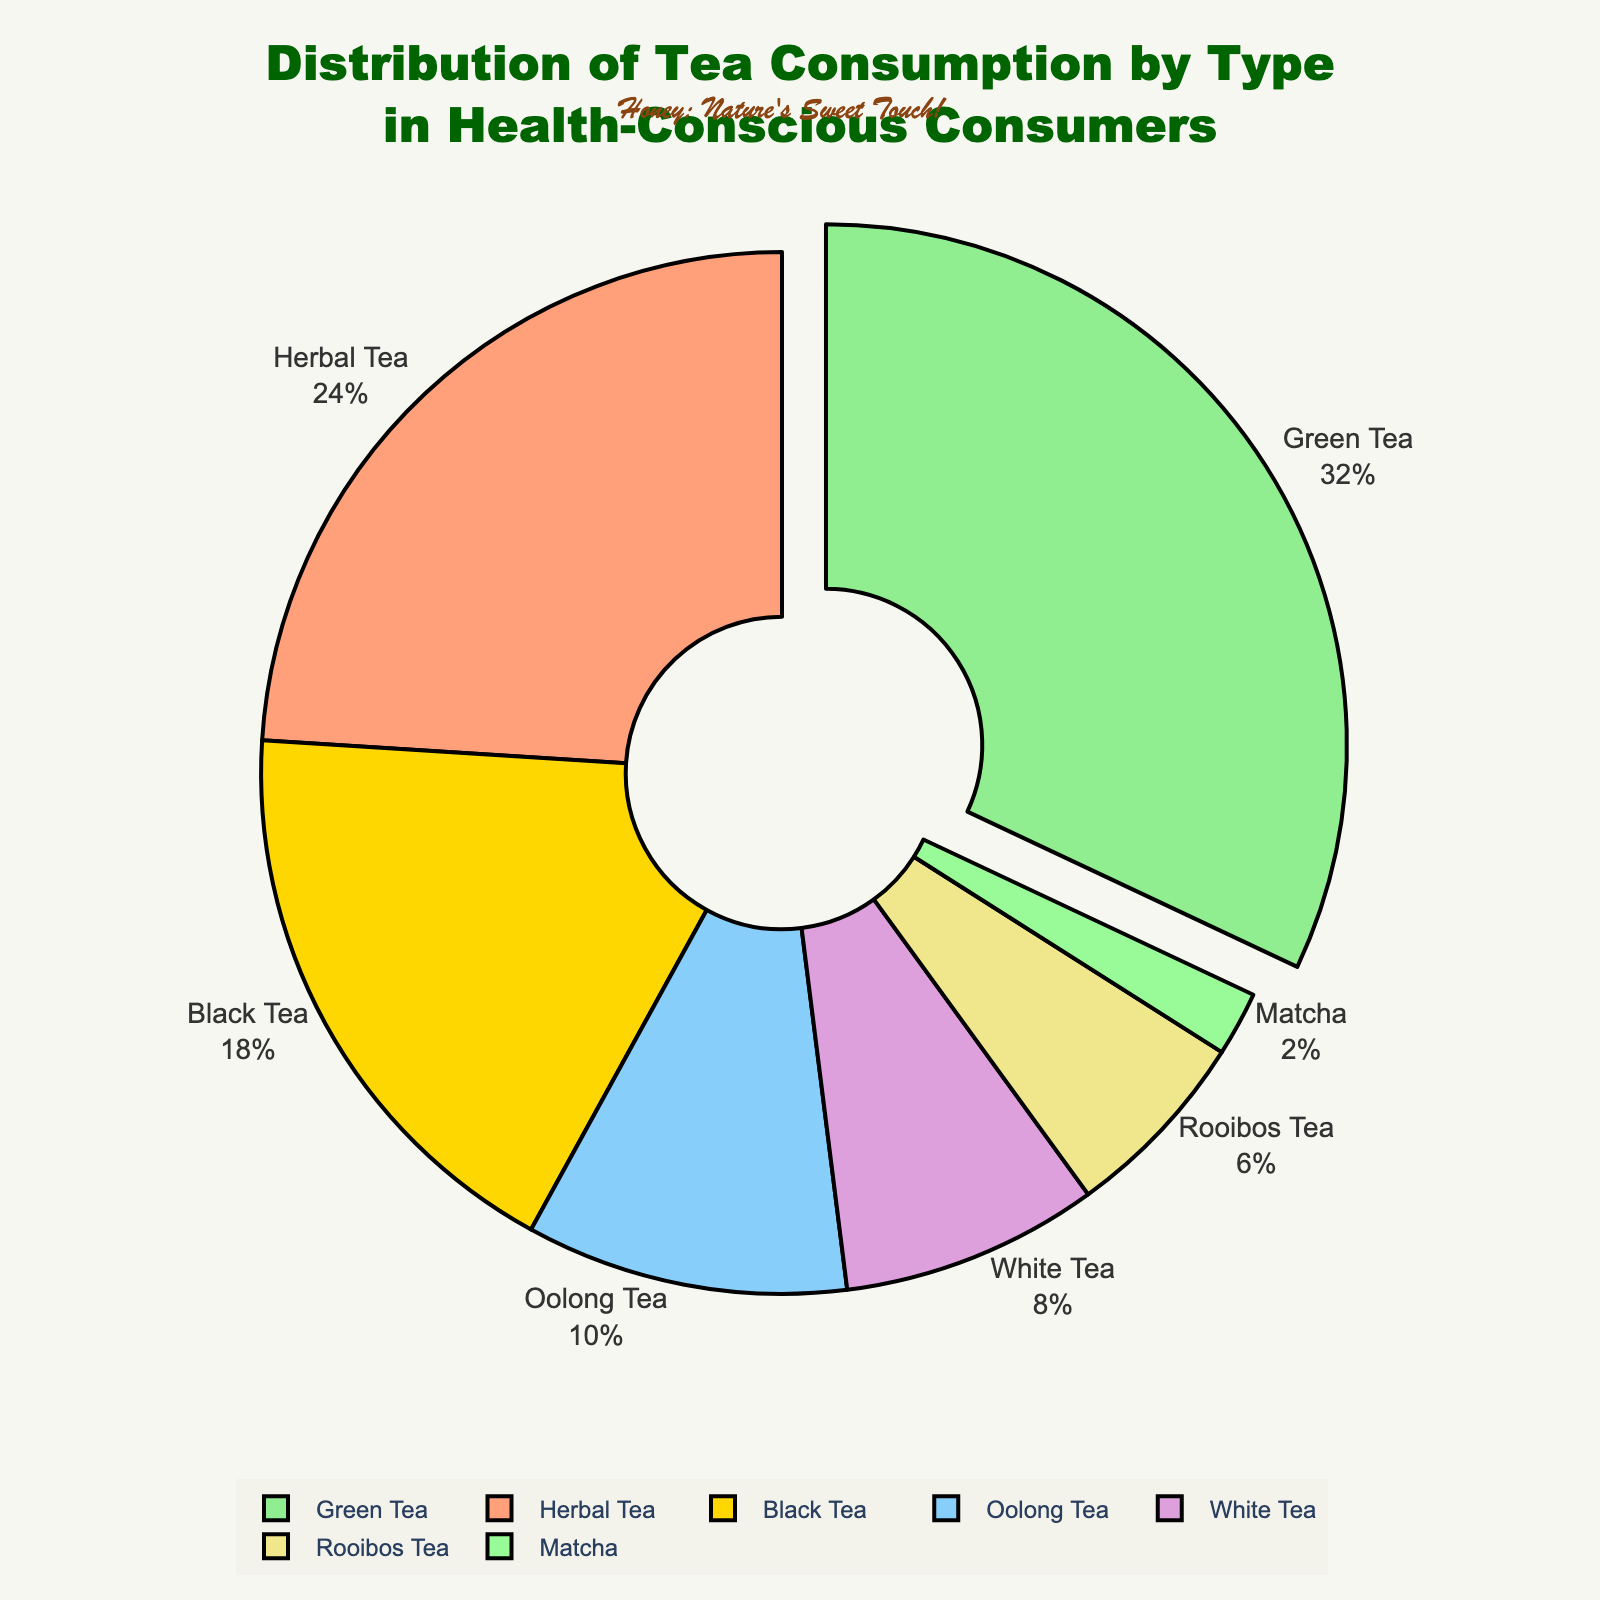What is the percentage of Green Tea consumption? Green Tea consumption is represented by the corresponding segment of the pie chart. It occupies 32% of the total.
Answer: 32% Which tea type has the lowest consumption among health-conscious consumers? By observing the pie chart, the smallest segment, labeled "Matcha," corresponds to 2%, indicating the lowest consumption.
Answer: Matcha How much higher is Green Tea consumption compared to Black Tea consumption? Green Tea consumption is 32% while Black Tea is 18%. The difference is 32% - 18% = 14%.
Answer: 14% Combine the percentages of Herbal Tea and Oolong Tea consumption. What is the total? Herbal Tea consumption is 24% and Oolong Tea is 10%. Adding these gives 24% + 10% = 34%.
Answer: 34% Which tea type has a higher consumption percentage, White Tea or Rooibos Tea? White Tea consumption is 8% while Rooibos Tea is 6%. Comparing these values, White Tea has a higher consumption percentage.
Answer: White Tea What is the combined consumption percentage of all the tea types that are consumed less than 10% each? The tea types consumed less than 10% are Oolong Tea (10%), White Tea (8%), Rooibos Tea (6%), and Matcha (2%). Summing these: 10% + 8% + 6% + 2% = 26%.
Answer: 26% By how much does Green Tea consumption exceed the sum of White Tea and Matcha Tea consumption? Green Tea consumption is 32%. The combined consumption of White Tea and Matcha is 8% + 2% = 10%. The difference is 32% - 10% = 22%.
Answer: 22% Which tea type is represented by the peach color in the pie chart? By visually inspecting the pie chart, the peach color corresponds to the segment labeled "Herbal Tea."
Answer: Herbal Tea Arrange the tea types in descending order of their consumption percentages. From the highest to the lowest consumption percentages: Green Tea (32%), Herbal Tea (24%), Black Tea (18%), Oolong Tea (10%), White Tea (8%), Rooibos Tea (6%), Matcha (2%).
Answer: Green Tea, Herbal Tea, Black Tea, Oolong Tea, White Tea, Rooibos Tea, Matcha 